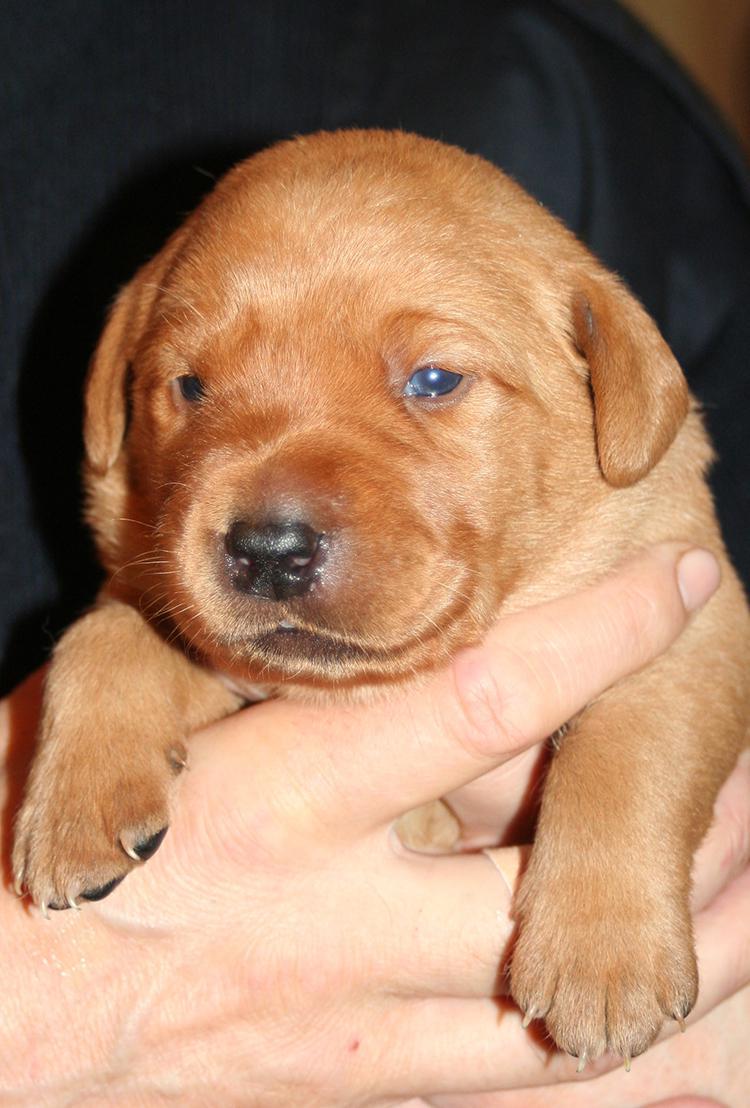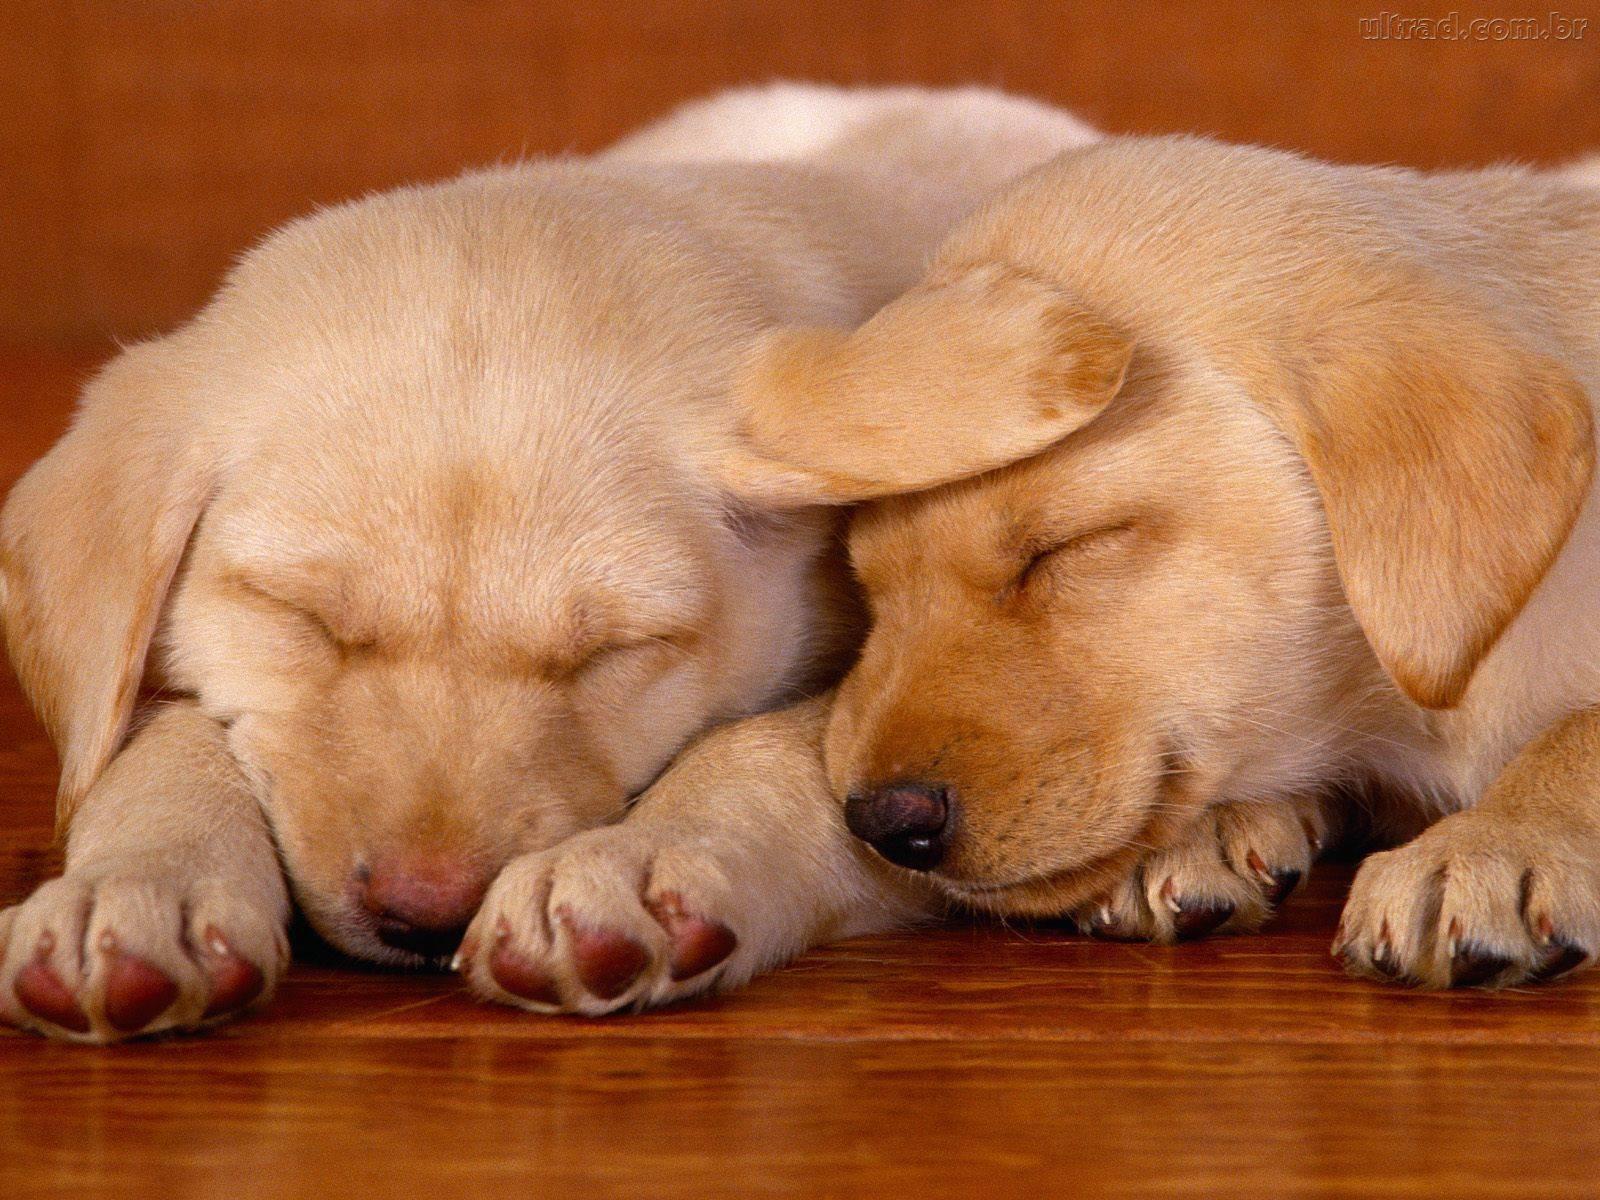The first image is the image on the left, the second image is the image on the right. Given the left and right images, does the statement "A puppy has a paw around a dark brownish-gray puppy that is reclining." hold true? Answer yes or no. No. The first image is the image on the left, the second image is the image on the right. Examine the images to the left and right. Is the description "Two dogs are lying down in the image on the left." accurate? Answer yes or no. No. 